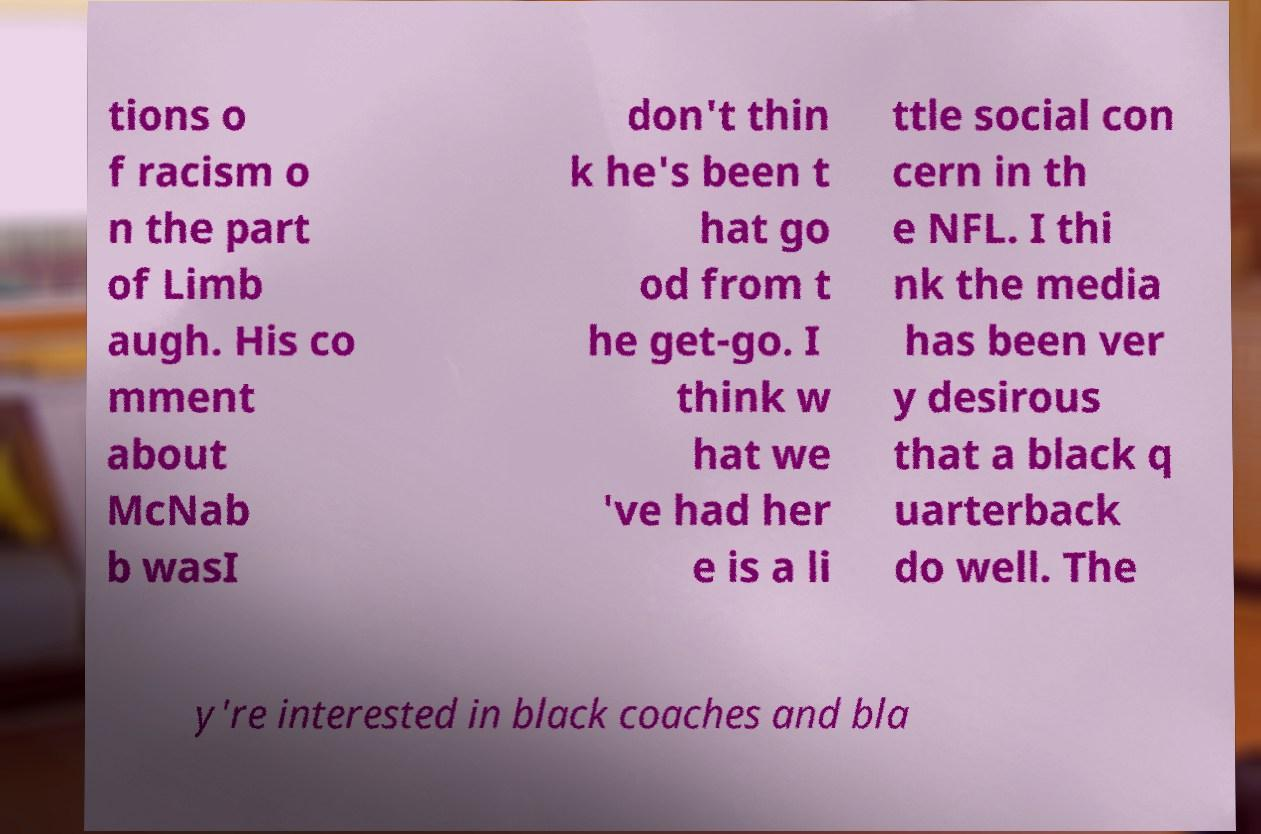Could you extract and type out the text from this image? tions o f racism o n the part of Limb augh. His co mment about McNab b wasI don't thin k he's been t hat go od from t he get-go. I think w hat we 've had her e is a li ttle social con cern in th e NFL. I thi nk the media has been ver y desirous that a black q uarterback do well. The y're interested in black coaches and bla 